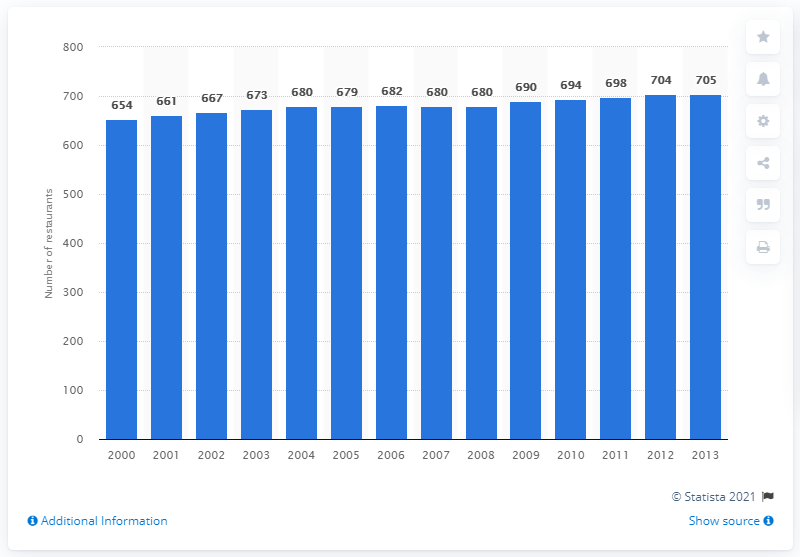Highlight a few significant elements in this photo. In 2013, there were 705 Red Lobster restaurants operating in North America. 